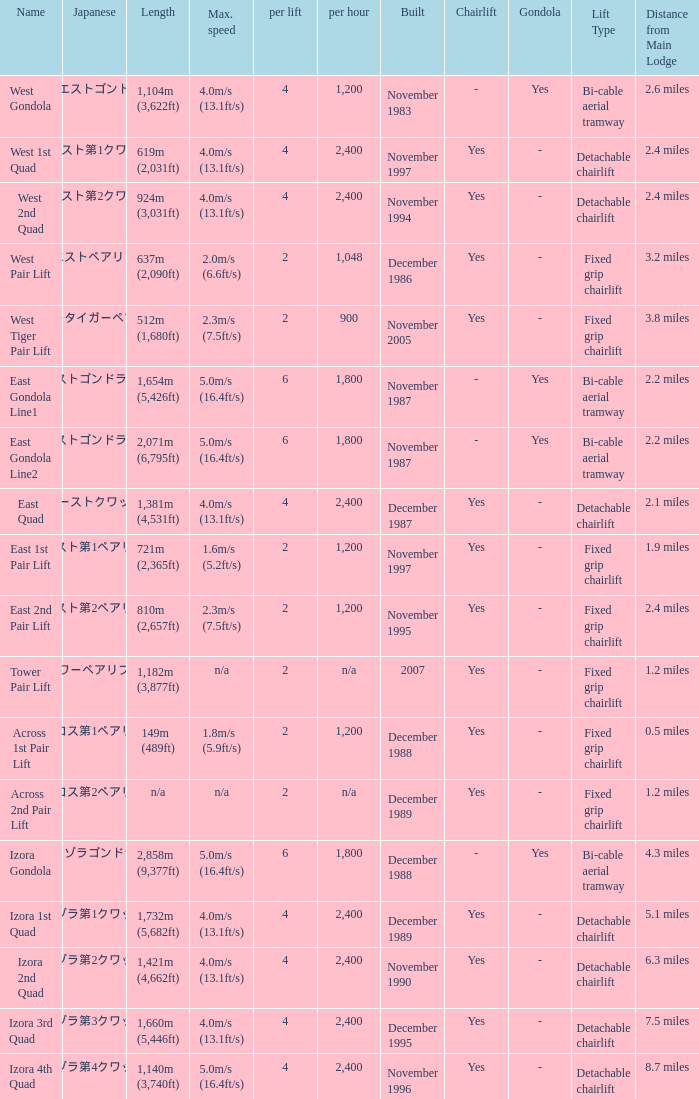How heavy is the  maximum 6.0. 